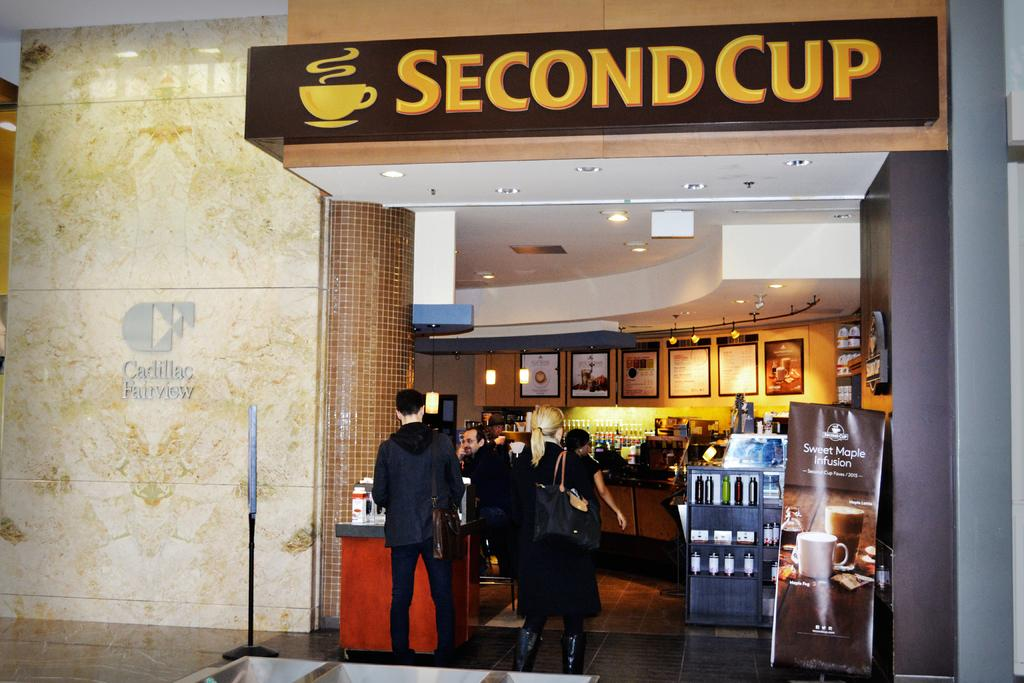<image>
Present a compact description of the photo's key features. People enter a busy coffee shop named second cup 